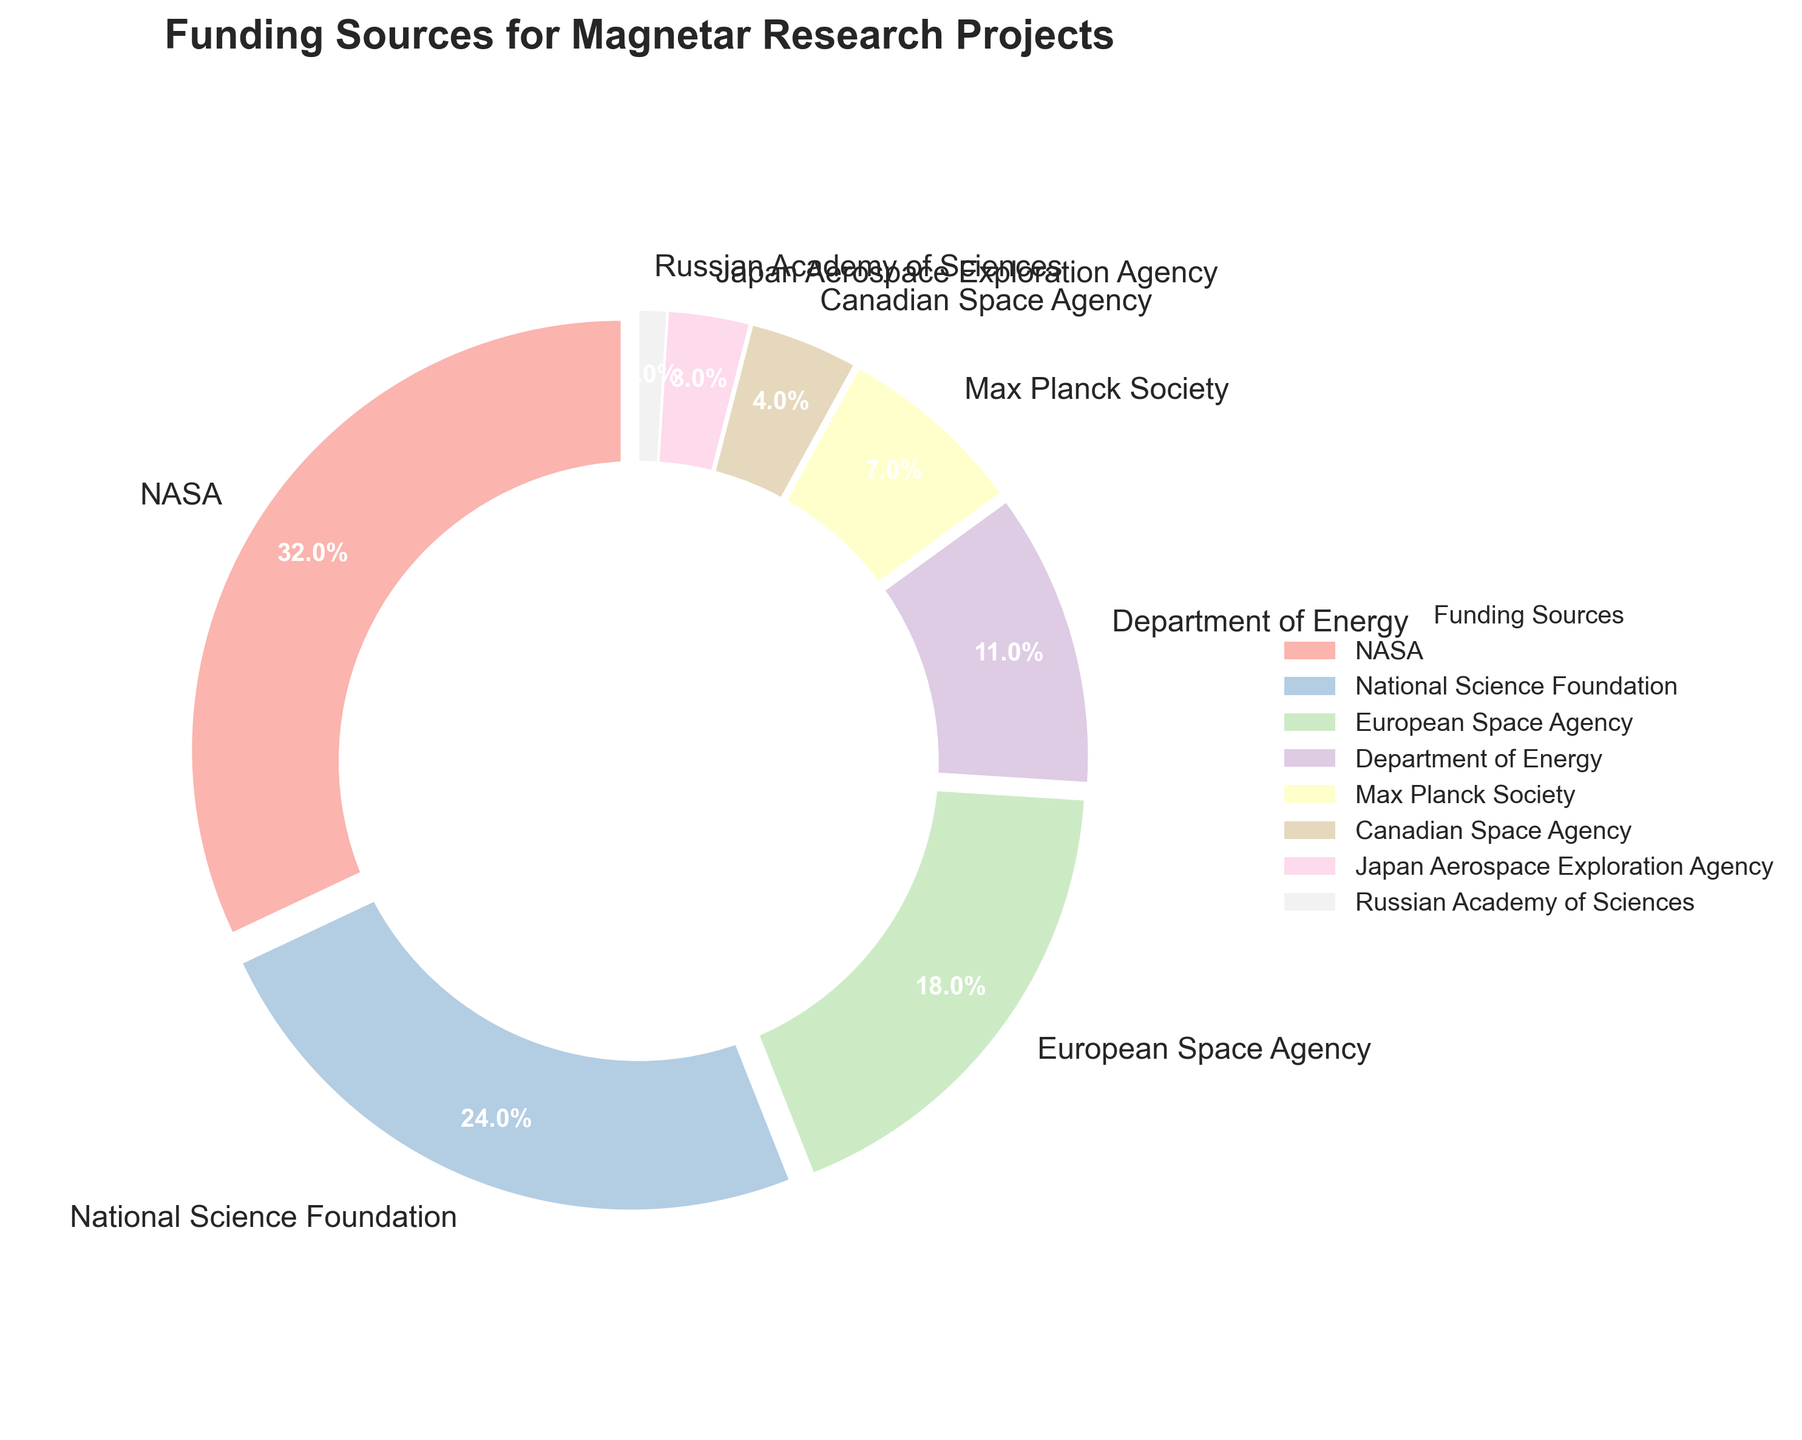What's the largest funding source in the pie chart? The largest funding source can be determined by looking for the segment with the highest percentage. In this case, it's NASA with 32%.
Answer: NASA Which funding sources together make up more than 50% of the total funding? Summing the percentages of the largest funding sources until we exceed 50%: NASA (32%) + National Science Foundation (24%) = 56%. These two sources together provide more than 50% of the total funding.
Answer: NASA and National Science Foundation Which funding source has the smallest contribution? The smallest contribution can be identified by looking for the segment with the lowest percentage. In this case, it's the Russian Academy of Sciences with 1%.
Answer: Russian Academy of Sciences What is the difference in percentage between the funding from the European Space Agency and the Department of Energy? Subtract the smaller percentage from the larger one: 18% (European Space Agency) - 11% (Department of Energy) = 7%.
Answer: 7% How many funding sources contribute less than 10% each? Identifying the segments with less than 10% contributions: Max Planck Society (7%), Canadian Space Agency (4%), Japan Aerospace Exploration Agency (3%), and Russian Academy of Sciences (1%). There are 4 such sources.
Answer: 4 Which segment in the pie chart has a red color? Observing the pie chart, the segment colored red corresponds to NASA.
Answer: NASA What percentage of the total funding comes from non-US sources? Summing the percentages of non-US funding sources: European Space Agency (18%) + Max Planck Society (7%) + Canadian Space Agency (4%) + Japan Aerospace Exploration Agency (3%) + Russian Academy of Sciences (1%) = 33%.
Answer: 33% Is the funding from NASA greater than the combined funding of the Canadian Space Agency and the Japanese Aerospace Exploration Agency? Adding the percentages of the combined sources: Canadian Space Agency (4%) + Japan Aerospace Exploration Agency (3%) = 7%. Since 32% (NASA) > 7%, the funding from NASA is indeed greater.
Answer: Yes What is the total percentage of funding coming from European organizations? Summing the percentages of European funding sources: European Space Agency (18%) + Max Planck Society (7%) = 25%.
Answer: 25% 